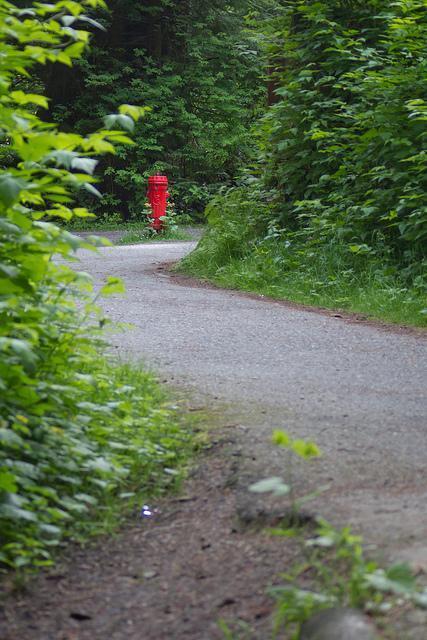How many cars are parked across the street?
Give a very brief answer. 0. 